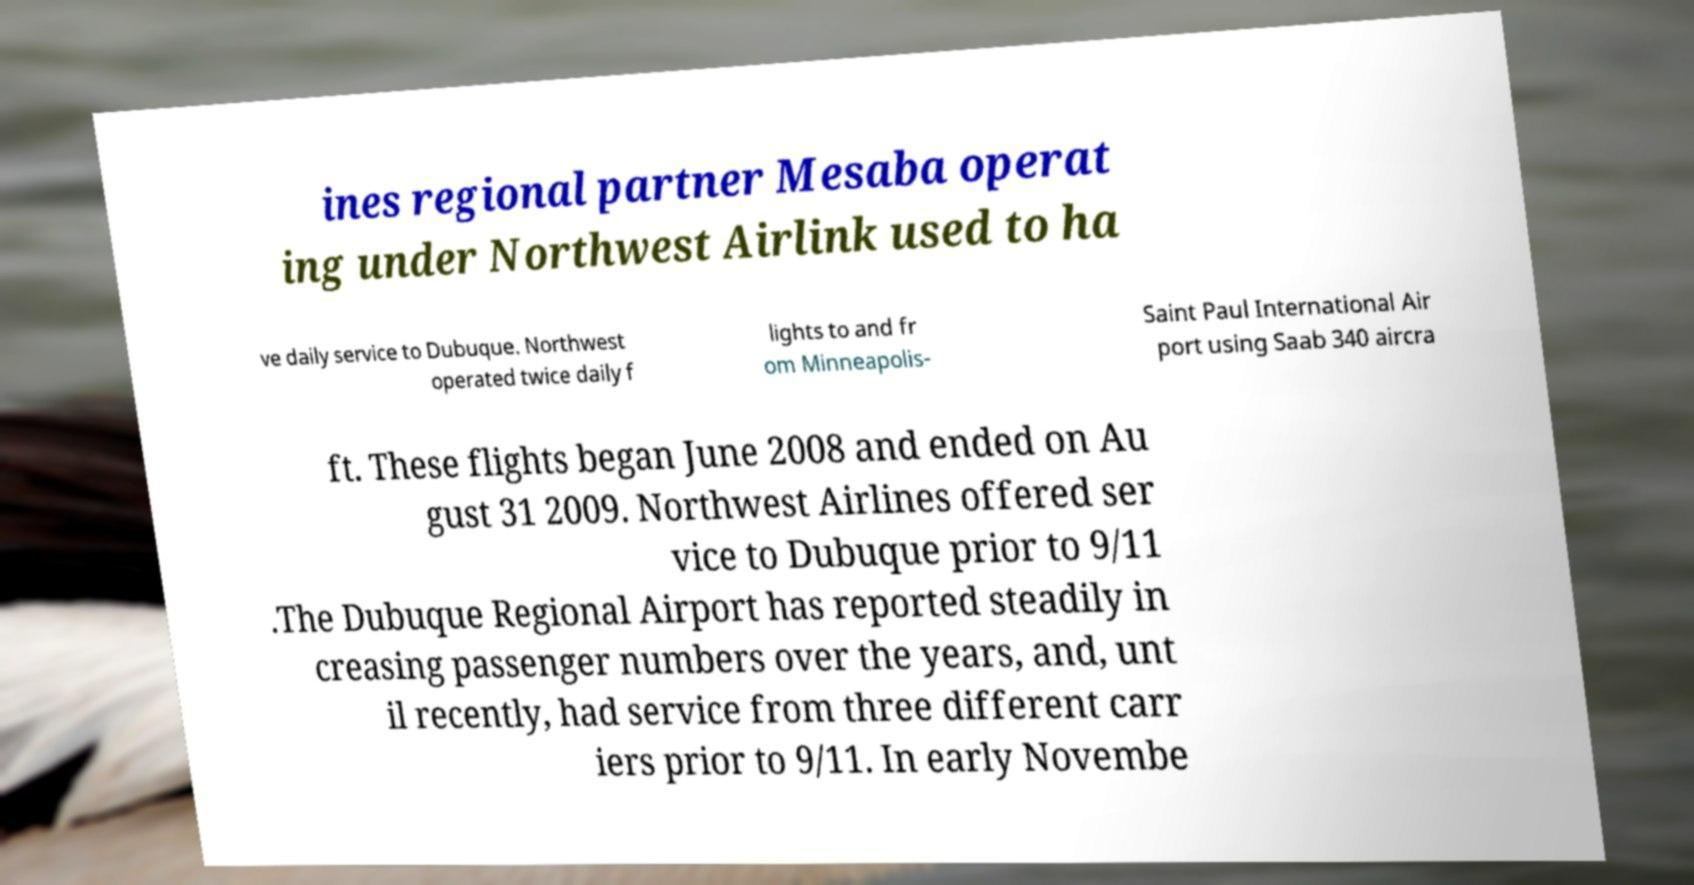For documentation purposes, I need the text within this image transcribed. Could you provide that? ines regional partner Mesaba operat ing under Northwest Airlink used to ha ve daily service to Dubuque. Northwest operated twice daily f lights to and fr om Minneapolis- Saint Paul International Air port using Saab 340 aircra ft. These flights began June 2008 and ended on Au gust 31 2009. Northwest Airlines offered ser vice to Dubuque prior to 9/11 .The Dubuque Regional Airport has reported steadily in creasing passenger numbers over the years, and, unt il recently, had service from three different carr iers prior to 9/11. In early Novembe 